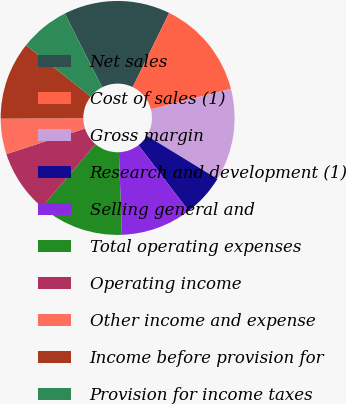<chart> <loc_0><loc_0><loc_500><loc_500><pie_chart><fcel>Net sales<fcel>Cost of sales (1)<fcel>Gross margin<fcel>Research and development (1)<fcel>Selling general and<fcel>Total operating expenses<fcel>Operating income<fcel>Other income and expense<fcel>Income before provision for<fcel>Provision for income taxes<nl><fcel>14.71%<fcel>13.73%<fcel>12.74%<fcel>5.88%<fcel>9.8%<fcel>11.76%<fcel>8.82%<fcel>4.9%<fcel>10.78%<fcel>6.86%<nl></chart> 